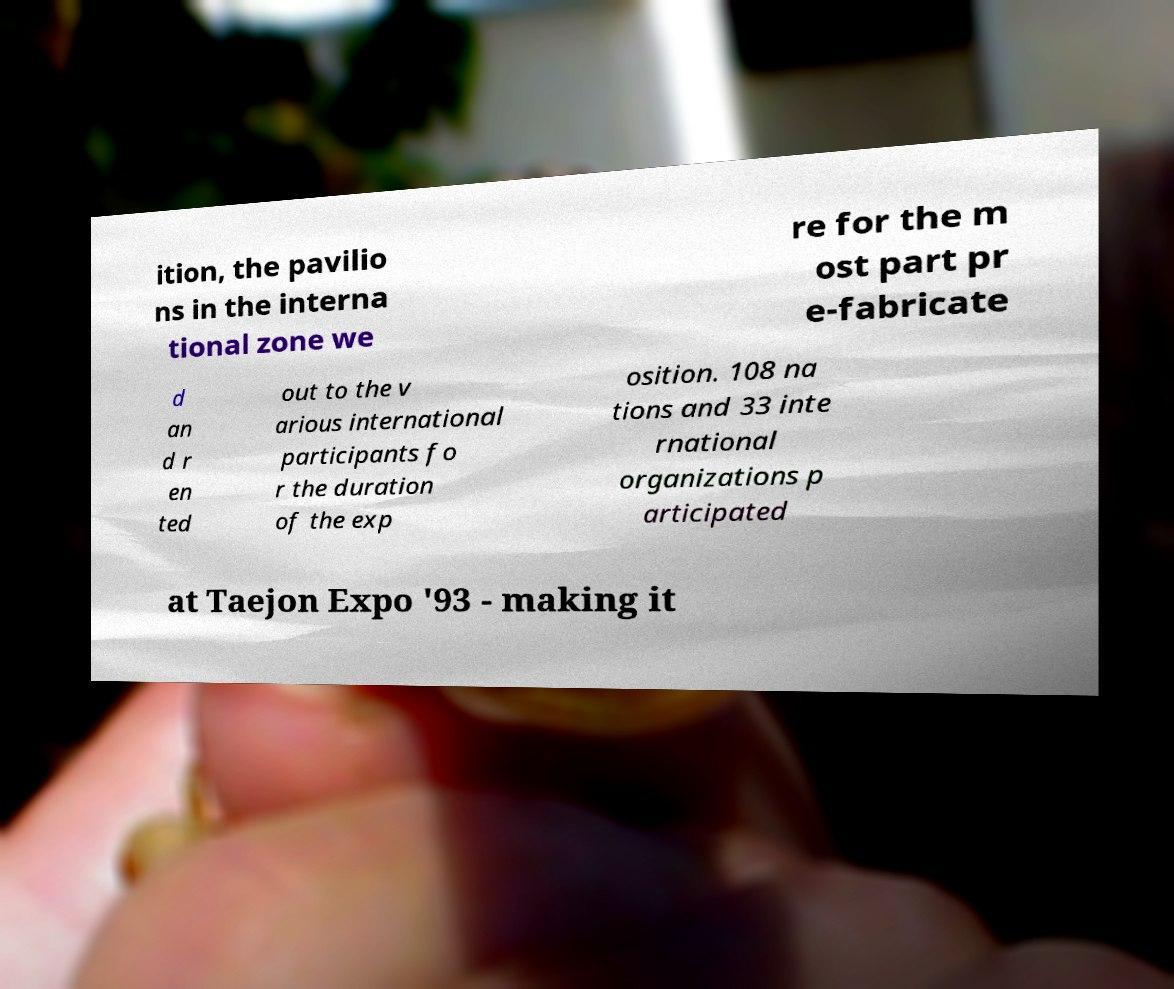There's text embedded in this image that I need extracted. Can you transcribe it verbatim? ition, the pavilio ns in the interna tional zone we re for the m ost part pr e-fabricate d an d r en ted out to the v arious international participants fo r the duration of the exp osition. 108 na tions and 33 inte rnational organizations p articipated at Taejon Expo '93 - making it 